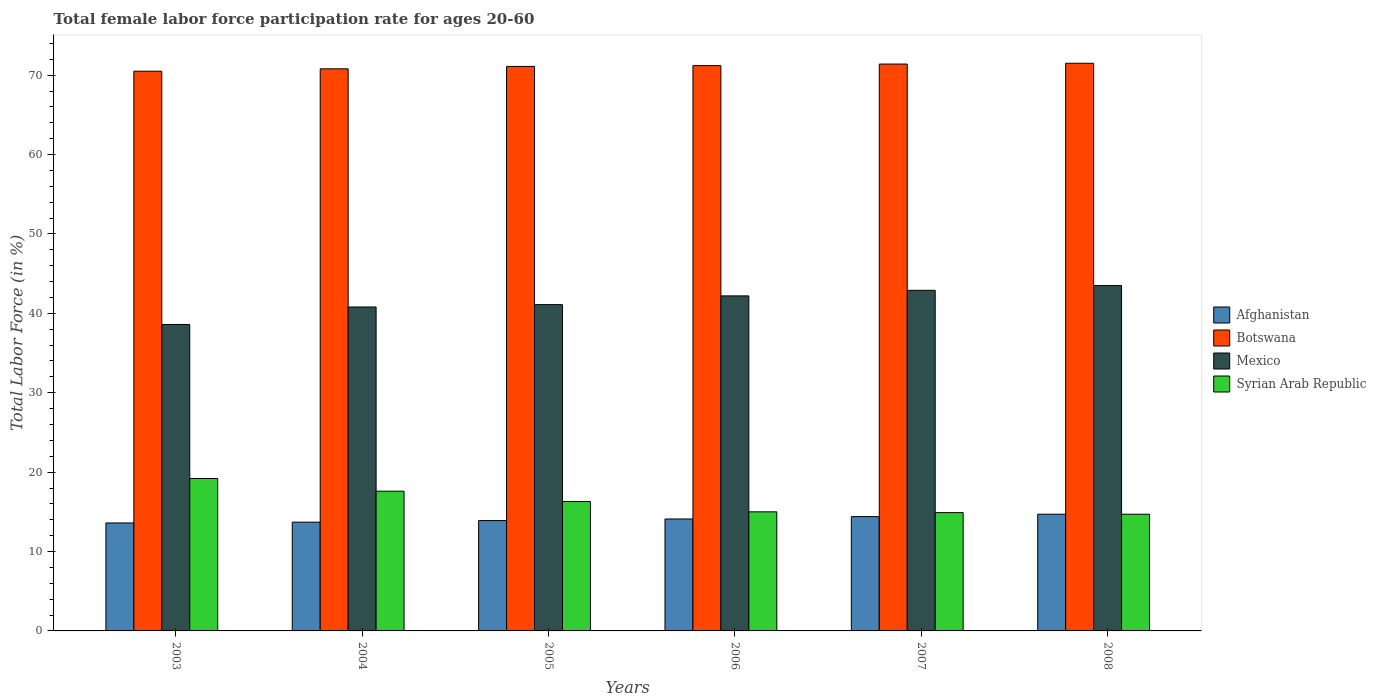How many groups of bars are there?
Offer a terse response. 6. Are the number of bars per tick equal to the number of legend labels?
Offer a very short reply. Yes. Are the number of bars on each tick of the X-axis equal?
Offer a very short reply. Yes. In how many cases, is the number of bars for a given year not equal to the number of legend labels?
Provide a short and direct response. 0. What is the female labor force participation rate in Syrian Arab Republic in 2006?
Your answer should be compact. 15. Across all years, what is the maximum female labor force participation rate in Botswana?
Keep it short and to the point. 71.5. Across all years, what is the minimum female labor force participation rate in Afghanistan?
Ensure brevity in your answer.  13.6. What is the total female labor force participation rate in Syrian Arab Republic in the graph?
Give a very brief answer. 97.7. What is the difference between the female labor force participation rate in Syrian Arab Republic in 2006 and that in 2008?
Provide a short and direct response. 0.3. What is the difference between the female labor force participation rate in Afghanistan in 2007 and the female labor force participation rate in Syrian Arab Republic in 2003?
Keep it short and to the point. -4.8. What is the average female labor force participation rate in Mexico per year?
Provide a succinct answer. 41.52. In the year 2006, what is the difference between the female labor force participation rate in Syrian Arab Republic and female labor force participation rate in Botswana?
Provide a short and direct response. -56.2. In how many years, is the female labor force participation rate in Syrian Arab Republic greater than 44 %?
Provide a succinct answer. 0. What is the ratio of the female labor force participation rate in Mexico in 2004 to that in 2006?
Ensure brevity in your answer.  0.97. Is the female labor force participation rate in Afghanistan in 2003 less than that in 2007?
Provide a short and direct response. Yes. Is the difference between the female labor force participation rate in Syrian Arab Republic in 2006 and 2007 greater than the difference between the female labor force participation rate in Botswana in 2006 and 2007?
Your answer should be compact. Yes. What is the difference between the highest and the second highest female labor force participation rate in Botswana?
Make the answer very short. 0.1. What is the difference between the highest and the lowest female labor force participation rate in Botswana?
Your answer should be very brief. 1. Is the sum of the female labor force participation rate in Syrian Arab Republic in 2005 and 2007 greater than the maximum female labor force participation rate in Afghanistan across all years?
Provide a short and direct response. Yes. What does the 3rd bar from the left in 2007 represents?
Your answer should be compact. Mexico. Is it the case that in every year, the sum of the female labor force participation rate in Afghanistan and female labor force participation rate in Mexico is greater than the female labor force participation rate in Botswana?
Offer a terse response. No. Are all the bars in the graph horizontal?
Your answer should be very brief. No. How many years are there in the graph?
Ensure brevity in your answer.  6. What is the difference between two consecutive major ticks on the Y-axis?
Ensure brevity in your answer.  10. How many legend labels are there?
Ensure brevity in your answer.  4. How are the legend labels stacked?
Ensure brevity in your answer.  Vertical. What is the title of the graph?
Your answer should be very brief. Total female labor force participation rate for ages 20-60. Does "Uzbekistan" appear as one of the legend labels in the graph?
Offer a terse response. No. What is the label or title of the X-axis?
Your answer should be compact. Years. What is the Total Labor Force (in %) of Afghanistan in 2003?
Your answer should be very brief. 13.6. What is the Total Labor Force (in %) of Botswana in 2003?
Your response must be concise. 70.5. What is the Total Labor Force (in %) of Mexico in 2003?
Your response must be concise. 38.6. What is the Total Labor Force (in %) in Syrian Arab Republic in 2003?
Give a very brief answer. 19.2. What is the Total Labor Force (in %) in Afghanistan in 2004?
Your answer should be very brief. 13.7. What is the Total Labor Force (in %) of Botswana in 2004?
Offer a very short reply. 70.8. What is the Total Labor Force (in %) in Mexico in 2004?
Make the answer very short. 40.8. What is the Total Labor Force (in %) in Syrian Arab Republic in 2004?
Offer a terse response. 17.6. What is the Total Labor Force (in %) of Afghanistan in 2005?
Your response must be concise. 13.9. What is the Total Labor Force (in %) of Botswana in 2005?
Keep it short and to the point. 71.1. What is the Total Labor Force (in %) of Mexico in 2005?
Your response must be concise. 41.1. What is the Total Labor Force (in %) of Syrian Arab Republic in 2005?
Ensure brevity in your answer.  16.3. What is the Total Labor Force (in %) of Afghanistan in 2006?
Offer a very short reply. 14.1. What is the Total Labor Force (in %) of Botswana in 2006?
Your answer should be compact. 71.2. What is the Total Labor Force (in %) of Mexico in 2006?
Your response must be concise. 42.2. What is the Total Labor Force (in %) of Syrian Arab Republic in 2006?
Provide a succinct answer. 15. What is the Total Labor Force (in %) of Afghanistan in 2007?
Give a very brief answer. 14.4. What is the Total Labor Force (in %) of Botswana in 2007?
Offer a terse response. 71.4. What is the Total Labor Force (in %) of Mexico in 2007?
Provide a succinct answer. 42.9. What is the Total Labor Force (in %) in Syrian Arab Republic in 2007?
Provide a short and direct response. 14.9. What is the Total Labor Force (in %) of Afghanistan in 2008?
Your answer should be compact. 14.7. What is the Total Labor Force (in %) of Botswana in 2008?
Your answer should be very brief. 71.5. What is the Total Labor Force (in %) in Mexico in 2008?
Make the answer very short. 43.5. What is the Total Labor Force (in %) of Syrian Arab Republic in 2008?
Offer a terse response. 14.7. Across all years, what is the maximum Total Labor Force (in %) in Afghanistan?
Offer a very short reply. 14.7. Across all years, what is the maximum Total Labor Force (in %) in Botswana?
Ensure brevity in your answer.  71.5. Across all years, what is the maximum Total Labor Force (in %) in Mexico?
Offer a terse response. 43.5. Across all years, what is the maximum Total Labor Force (in %) of Syrian Arab Republic?
Your answer should be compact. 19.2. Across all years, what is the minimum Total Labor Force (in %) of Afghanistan?
Keep it short and to the point. 13.6. Across all years, what is the minimum Total Labor Force (in %) in Botswana?
Offer a very short reply. 70.5. Across all years, what is the minimum Total Labor Force (in %) of Mexico?
Offer a terse response. 38.6. Across all years, what is the minimum Total Labor Force (in %) of Syrian Arab Republic?
Your response must be concise. 14.7. What is the total Total Labor Force (in %) in Afghanistan in the graph?
Your response must be concise. 84.4. What is the total Total Labor Force (in %) of Botswana in the graph?
Your response must be concise. 426.5. What is the total Total Labor Force (in %) in Mexico in the graph?
Your answer should be very brief. 249.1. What is the total Total Labor Force (in %) of Syrian Arab Republic in the graph?
Ensure brevity in your answer.  97.7. What is the difference between the Total Labor Force (in %) of Syrian Arab Republic in 2003 and that in 2004?
Make the answer very short. 1.6. What is the difference between the Total Labor Force (in %) of Mexico in 2003 and that in 2005?
Keep it short and to the point. -2.5. What is the difference between the Total Labor Force (in %) in Afghanistan in 2003 and that in 2006?
Your answer should be very brief. -0.5. What is the difference between the Total Labor Force (in %) of Botswana in 2003 and that in 2006?
Your answer should be compact. -0.7. What is the difference between the Total Labor Force (in %) of Mexico in 2003 and that in 2006?
Ensure brevity in your answer.  -3.6. What is the difference between the Total Labor Force (in %) in Syrian Arab Republic in 2003 and that in 2006?
Provide a short and direct response. 4.2. What is the difference between the Total Labor Force (in %) in Botswana in 2003 and that in 2007?
Offer a very short reply. -0.9. What is the difference between the Total Labor Force (in %) in Mexico in 2003 and that in 2007?
Make the answer very short. -4.3. What is the difference between the Total Labor Force (in %) in Afghanistan in 2004 and that in 2005?
Your response must be concise. -0.2. What is the difference between the Total Labor Force (in %) in Botswana in 2004 and that in 2005?
Keep it short and to the point. -0.3. What is the difference between the Total Labor Force (in %) of Mexico in 2004 and that in 2005?
Ensure brevity in your answer.  -0.3. What is the difference between the Total Labor Force (in %) in Syrian Arab Republic in 2004 and that in 2005?
Provide a succinct answer. 1.3. What is the difference between the Total Labor Force (in %) of Botswana in 2004 and that in 2006?
Offer a terse response. -0.4. What is the difference between the Total Labor Force (in %) in Mexico in 2004 and that in 2006?
Make the answer very short. -1.4. What is the difference between the Total Labor Force (in %) in Botswana in 2004 and that in 2007?
Ensure brevity in your answer.  -0.6. What is the difference between the Total Labor Force (in %) in Syrian Arab Republic in 2004 and that in 2007?
Offer a very short reply. 2.7. What is the difference between the Total Labor Force (in %) in Botswana in 2004 and that in 2008?
Offer a terse response. -0.7. What is the difference between the Total Labor Force (in %) in Mexico in 2004 and that in 2008?
Ensure brevity in your answer.  -2.7. What is the difference between the Total Labor Force (in %) in Syrian Arab Republic in 2004 and that in 2008?
Your response must be concise. 2.9. What is the difference between the Total Labor Force (in %) of Afghanistan in 2005 and that in 2006?
Your answer should be very brief. -0.2. What is the difference between the Total Labor Force (in %) in Botswana in 2005 and that in 2006?
Your response must be concise. -0.1. What is the difference between the Total Labor Force (in %) in Syrian Arab Republic in 2005 and that in 2006?
Offer a terse response. 1.3. What is the difference between the Total Labor Force (in %) of Botswana in 2005 and that in 2007?
Make the answer very short. -0.3. What is the difference between the Total Labor Force (in %) of Syrian Arab Republic in 2005 and that in 2007?
Offer a very short reply. 1.4. What is the difference between the Total Labor Force (in %) of Afghanistan in 2005 and that in 2008?
Ensure brevity in your answer.  -0.8. What is the difference between the Total Labor Force (in %) of Afghanistan in 2006 and that in 2007?
Keep it short and to the point. -0.3. What is the difference between the Total Labor Force (in %) in Botswana in 2006 and that in 2007?
Your answer should be compact. -0.2. What is the difference between the Total Labor Force (in %) in Afghanistan in 2006 and that in 2008?
Offer a terse response. -0.6. What is the difference between the Total Labor Force (in %) of Botswana in 2006 and that in 2008?
Your answer should be very brief. -0.3. What is the difference between the Total Labor Force (in %) of Mexico in 2006 and that in 2008?
Provide a short and direct response. -1.3. What is the difference between the Total Labor Force (in %) in Syrian Arab Republic in 2006 and that in 2008?
Your response must be concise. 0.3. What is the difference between the Total Labor Force (in %) in Afghanistan in 2007 and that in 2008?
Give a very brief answer. -0.3. What is the difference between the Total Labor Force (in %) of Botswana in 2007 and that in 2008?
Your response must be concise. -0.1. What is the difference between the Total Labor Force (in %) in Mexico in 2007 and that in 2008?
Give a very brief answer. -0.6. What is the difference between the Total Labor Force (in %) in Afghanistan in 2003 and the Total Labor Force (in %) in Botswana in 2004?
Offer a very short reply. -57.2. What is the difference between the Total Labor Force (in %) of Afghanistan in 2003 and the Total Labor Force (in %) of Mexico in 2004?
Make the answer very short. -27.2. What is the difference between the Total Labor Force (in %) in Botswana in 2003 and the Total Labor Force (in %) in Mexico in 2004?
Keep it short and to the point. 29.7. What is the difference between the Total Labor Force (in %) of Botswana in 2003 and the Total Labor Force (in %) of Syrian Arab Republic in 2004?
Keep it short and to the point. 52.9. What is the difference between the Total Labor Force (in %) of Afghanistan in 2003 and the Total Labor Force (in %) of Botswana in 2005?
Make the answer very short. -57.5. What is the difference between the Total Labor Force (in %) of Afghanistan in 2003 and the Total Labor Force (in %) of Mexico in 2005?
Your response must be concise. -27.5. What is the difference between the Total Labor Force (in %) in Botswana in 2003 and the Total Labor Force (in %) in Mexico in 2005?
Make the answer very short. 29.4. What is the difference between the Total Labor Force (in %) in Botswana in 2003 and the Total Labor Force (in %) in Syrian Arab Republic in 2005?
Ensure brevity in your answer.  54.2. What is the difference between the Total Labor Force (in %) of Mexico in 2003 and the Total Labor Force (in %) of Syrian Arab Republic in 2005?
Offer a terse response. 22.3. What is the difference between the Total Labor Force (in %) of Afghanistan in 2003 and the Total Labor Force (in %) of Botswana in 2006?
Offer a very short reply. -57.6. What is the difference between the Total Labor Force (in %) of Afghanistan in 2003 and the Total Labor Force (in %) of Mexico in 2006?
Give a very brief answer. -28.6. What is the difference between the Total Labor Force (in %) of Afghanistan in 2003 and the Total Labor Force (in %) of Syrian Arab Republic in 2006?
Provide a succinct answer. -1.4. What is the difference between the Total Labor Force (in %) of Botswana in 2003 and the Total Labor Force (in %) of Mexico in 2006?
Give a very brief answer. 28.3. What is the difference between the Total Labor Force (in %) of Botswana in 2003 and the Total Labor Force (in %) of Syrian Arab Republic in 2006?
Keep it short and to the point. 55.5. What is the difference between the Total Labor Force (in %) of Mexico in 2003 and the Total Labor Force (in %) of Syrian Arab Republic in 2006?
Ensure brevity in your answer.  23.6. What is the difference between the Total Labor Force (in %) of Afghanistan in 2003 and the Total Labor Force (in %) of Botswana in 2007?
Give a very brief answer. -57.8. What is the difference between the Total Labor Force (in %) in Afghanistan in 2003 and the Total Labor Force (in %) in Mexico in 2007?
Your response must be concise. -29.3. What is the difference between the Total Labor Force (in %) in Botswana in 2003 and the Total Labor Force (in %) in Mexico in 2007?
Keep it short and to the point. 27.6. What is the difference between the Total Labor Force (in %) in Botswana in 2003 and the Total Labor Force (in %) in Syrian Arab Republic in 2007?
Your answer should be compact. 55.6. What is the difference between the Total Labor Force (in %) of Mexico in 2003 and the Total Labor Force (in %) of Syrian Arab Republic in 2007?
Offer a terse response. 23.7. What is the difference between the Total Labor Force (in %) in Afghanistan in 2003 and the Total Labor Force (in %) in Botswana in 2008?
Your response must be concise. -57.9. What is the difference between the Total Labor Force (in %) of Afghanistan in 2003 and the Total Labor Force (in %) of Mexico in 2008?
Keep it short and to the point. -29.9. What is the difference between the Total Labor Force (in %) of Afghanistan in 2003 and the Total Labor Force (in %) of Syrian Arab Republic in 2008?
Make the answer very short. -1.1. What is the difference between the Total Labor Force (in %) of Botswana in 2003 and the Total Labor Force (in %) of Syrian Arab Republic in 2008?
Your answer should be very brief. 55.8. What is the difference between the Total Labor Force (in %) of Mexico in 2003 and the Total Labor Force (in %) of Syrian Arab Republic in 2008?
Offer a very short reply. 23.9. What is the difference between the Total Labor Force (in %) in Afghanistan in 2004 and the Total Labor Force (in %) in Botswana in 2005?
Provide a short and direct response. -57.4. What is the difference between the Total Labor Force (in %) in Afghanistan in 2004 and the Total Labor Force (in %) in Mexico in 2005?
Offer a terse response. -27.4. What is the difference between the Total Labor Force (in %) in Botswana in 2004 and the Total Labor Force (in %) in Mexico in 2005?
Your answer should be compact. 29.7. What is the difference between the Total Labor Force (in %) in Botswana in 2004 and the Total Labor Force (in %) in Syrian Arab Republic in 2005?
Provide a succinct answer. 54.5. What is the difference between the Total Labor Force (in %) in Mexico in 2004 and the Total Labor Force (in %) in Syrian Arab Republic in 2005?
Your response must be concise. 24.5. What is the difference between the Total Labor Force (in %) in Afghanistan in 2004 and the Total Labor Force (in %) in Botswana in 2006?
Make the answer very short. -57.5. What is the difference between the Total Labor Force (in %) of Afghanistan in 2004 and the Total Labor Force (in %) of Mexico in 2006?
Offer a very short reply. -28.5. What is the difference between the Total Labor Force (in %) in Botswana in 2004 and the Total Labor Force (in %) in Mexico in 2006?
Ensure brevity in your answer.  28.6. What is the difference between the Total Labor Force (in %) of Botswana in 2004 and the Total Labor Force (in %) of Syrian Arab Republic in 2006?
Provide a short and direct response. 55.8. What is the difference between the Total Labor Force (in %) in Mexico in 2004 and the Total Labor Force (in %) in Syrian Arab Republic in 2006?
Offer a terse response. 25.8. What is the difference between the Total Labor Force (in %) in Afghanistan in 2004 and the Total Labor Force (in %) in Botswana in 2007?
Offer a terse response. -57.7. What is the difference between the Total Labor Force (in %) in Afghanistan in 2004 and the Total Labor Force (in %) in Mexico in 2007?
Give a very brief answer. -29.2. What is the difference between the Total Labor Force (in %) of Afghanistan in 2004 and the Total Labor Force (in %) of Syrian Arab Republic in 2007?
Offer a very short reply. -1.2. What is the difference between the Total Labor Force (in %) of Botswana in 2004 and the Total Labor Force (in %) of Mexico in 2007?
Ensure brevity in your answer.  27.9. What is the difference between the Total Labor Force (in %) in Botswana in 2004 and the Total Labor Force (in %) in Syrian Arab Republic in 2007?
Your answer should be very brief. 55.9. What is the difference between the Total Labor Force (in %) of Mexico in 2004 and the Total Labor Force (in %) of Syrian Arab Republic in 2007?
Your answer should be very brief. 25.9. What is the difference between the Total Labor Force (in %) in Afghanistan in 2004 and the Total Labor Force (in %) in Botswana in 2008?
Make the answer very short. -57.8. What is the difference between the Total Labor Force (in %) of Afghanistan in 2004 and the Total Labor Force (in %) of Mexico in 2008?
Provide a short and direct response. -29.8. What is the difference between the Total Labor Force (in %) in Afghanistan in 2004 and the Total Labor Force (in %) in Syrian Arab Republic in 2008?
Ensure brevity in your answer.  -1. What is the difference between the Total Labor Force (in %) in Botswana in 2004 and the Total Labor Force (in %) in Mexico in 2008?
Provide a short and direct response. 27.3. What is the difference between the Total Labor Force (in %) in Botswana in 2004 and the Total Labor Force (in %) in Syrian Arab Republic in 2008?
Make the answer very short. 56.1. What is the difference between the Total Labor Force (in %) of Mexico in 2004 and the Total Labor Force (in %) of Syrian Arab Republic in 2008?
Ensure brevity in your answer.  26.1. What is the difference between the Total Labor Force (in %) of Afghanistan in 2005 and the Total Labor Force (in %) of Botswana in 2006?
Make the answer very short. -57.3. What is the difference between the Total Labor Force (in %) of Afghanistan in 2005 and the Total Labor Force (in %) of Mexico in 2006?
Provide a succinct answer. -28.3. What is the difference between the Total Labor Force (in %) in Botswana in 2005 and the Total Labor Force (in %) in Mexico in 2006?
Offer a terse response. 28.9. What is the difference between the Total Labor Force (in %) in Botswana in 2005 and the Total Labor Force (in %) in Syrian Arab Republic in 2006?
Your answer should be very brief. 56.1. What is the difference between the Total Labor Force (in %) in Mexico in 2005 and the Total Labor Force (in %) in Syrian Arab Republic in 2006?
Keep it short and to the point. 26.1. What is the difference between the Total Labor Force (in %) in Afghanistan in 2005 and the Total Labor Force (in %) in Botswana in 2007?
Provide a succinct answer. -57.5. What is the difference between the Total Labor Force (in %) of Afghanistan in 2005 and the Total Labor Force (in %) of Mexico in 2007?
Your answer should be very brief. -29. What is the difference between the Total Labor Force (in %) in Afghanistan in 2005 and the Total Labor Force (in %) in Syrian Arab Republic in 2007?
Offer a very short reply. -1. What is the difference between the Total Labor Force (in %) in Botswana in 2005 and the Total Labor Force (in %) in Mexico in 2007?
Give a very brief answer. 28.2. What is the difference between the Total Labor Force (in %) in Botswana in 2005 and the Total Labor Force (in %) in Syrian Arab Republic in 2007?
Provide a succinct answer. 56.2. What is the difference between the Total Labor Force (in %) in Mexico in 2005 and the Total Labor Force (in %) in Syrian Arab Republic in 2007?
Provide a short and direct response. 26.2. What is the difference between the Total Labor Force (in %) in Afghanistan in 2005 and the Total Labor Force (in %) in Botswana in 2008?
Ensure brevity in your answer.  -57.6. What is the difference between the Total Labor Force (in %) in Afghanistan in 2005 and the Total Labor Force (in %) in Mexico in 2008?
Your answer should be very brief. -29.6. What is the difference between the Total Labor Force (in %) of Botswana in 2005 and the Total Labor Force (in %) of Mexico in 2008?
Offer a very short reply. 27.6. What is the difference between the Total Labor Force (in %) of Botswana in 2005 and the Total Labor Force (in %) of Syrian Arab Republic in 2008?
Make the answer very short. 56.4. What is the difference between the Total Labor Force (in %) of Mexico in 2005 and the Total Labor Force (in %) of Syrian Arab Republic in 2008?
Offer a terse response. 26.4. What is the difference between the Total Labor Force (in %) of Afghanistan in 2006 and the Total Labor Force (in %) of Botswana in 2007?
Offer a very short reply. -57.3. What is the difference between the Total Labor Force (in %) in Afghanistan in 2006 and the Total Labor Force (in %) in Mexico in 2007?
Ensure brevity in your answer.  -28.8. What is the difference between the Total Labor Force (in %) of Afghanistan in 2006 and the Total Labor Force (in %) of Syrian Arab Republic in 2007?
Provide a succinct answer. -0.8. What is the difference between the Total Labor Force (in %) of Botswana in 2006 and the Total Labor Force (in %) of Mexico in 2007?
Keep it short and to the point. 28.3. What is the difference between the Total Labor Force (in %) in Botswana in 2006 and the Total Labor Force (in %) in Syrian Arab Republic in 2007?
Provide a short and direct response. 56.3. What is the difference between the Total Labor Force (in %) in Mexico in 2006 and the Total Labor Force (in %) in Syrian Arab Republic in 2007?
Keep it short and to the point. 27.3. What is the difference between the Total Labor Force (in %) in Afghanistan in 2006 and the Total Labor Force (in %) in Botswana in 2008?
Provide a short and direct response. -57.4. What is the difference between the Total Labor Force (in %) of Afghanistan in 2006 and the Total Labor Force (in %) of Mexico in 2008?
Your answer should be very brief. -29.4. What is the difference between the Total Labor Force (in %) in Afghanistan in 2006 and the Total Labor Force (in %) in Syrian Arab Republic in 2008?
Ensure brevity in your answer.  -0.6. What is the difference between the Total Labor Force (in %) in Botswana in 2006 and the Total Labor Force (in %) in Mexico in 2008?
Offer a terse response. 27.7. What is the difference between the Total Labor Force (in %) of Botswana in 2006 and the Total Labor Force (in %) of Syrian Arab Republic in 2008?
Keep it short and to the point. 56.5. What is the difference between the Total Labor Force (in %) of Afghanistan in 2007 and the Total Labor Force (in %) of Botswana in 2008?
Your answer should be compact. -57.1. What is the difference between the Total Labor Force (in %) of Afghanistan in 2007 and the Total Labor Force (in %) of Mexico in 2008?
Your answer should be compact. -29.1. What is the difference between the Total Labor Force (in %) in Afghanistan in 2007 and the Total Labor Force (in %) in Syrian Arab Republic in 2008?
Provide a succinct answer. -0.3. What is the difference between the Total Labor Force (in %) in Botswana in 2007 and the Total Labor Force (in %) in Mexico in 2008?
Give a very brief answer. 27.9. What is the difference between the Total Labor Force (in %) in Botswana in 2007 and the Total Labor Force (in %) in Syrian Arab Republic in 2008?
Give a very brief answer. 56.7. What is the difference between the Total Labor Force (in %) in Mexico in 2007 and the Total Labor Force (in %) in Syrian Arab Republic in 2008?
Your answer should be very brief. 28.2. What is the average Total Labor Force (in %) of Afghanistan per year?
Your answer should be very brief. 14.07. What is the average Total Labor Force (in %) in Botswana per year?
Offer a terse response. 71.08. What is the average Total Labor Force (in %) of Mexico per year?
Make the answer very short. 41.52. What is the average Total Labor Force (in %) in Syrian Arab Republic per year?
Your answer should be compact. 16.28. In the year 2003, what is the difference between the Total Labor Force (in %) in Afghanistan and Total Labor Force (in %) in Botswana?
Your answer should be very brief. -56.9. In the year 2003, what is the difference between the Total Labor Force (in %) in Botswana and Total Labor Force (in %) in Mexico?
Ensure brevity in your answer.  31.9. In the year 2003, what is the difference between the Total Labor Force (in %) of Botswana and Total Labor Force (in %) of Syrian Arab Republic?
Your answer should be compact. 51.3. In the year 2003, what is the difference between the Total Labor Force (in %) of Mexico and Total Labor Force (in %) of Syrian Arab Republic?
Your answer should be compact. 19.4. In the year 2004, what is the difference between the Total Labor Force (in %) of Afghanistan and Total Labor Force (in %) of Botswana?
Your answer should be compact. -57.1. In the year 2004, what is the difference between the Total Labor Force (in %) in Afghanistan and Total Labor Force (in %) in Mexico?
Ensure brevity in your answer.  -27.1. In the year 2004, what is the difference between the Total Labor Force (in %) of Afghanistan and Total Labor Force (in %) of Syrian Arab Republic?
Your response must be concise. -3.9. In the year 2004, what is the difference between the Total Labor Force (in %) in Botswana and Total Labor Force (in %) in Mexico?
Your answer should be compact. 30. In the year 2004, what is the difference between the Total Labor Force (in %) in Botswana and Total Labor Force (in %) in Syrian Arab Republic?
Offer a very short reply. 53.2. In the year 2004, what is the difference between the Total Labor Force (in %) in Mexico and Total Labor Force (in %) in Syrian Arab Republic?
Keep it short and to the point. 23.2. In the year 2005, what is the difference between the Total Labor Force (in %) in Afghanistan and Total Labor Force (in %) in Botswana?
Make the answer very short. -57.2. In the year 2005, what is the difference between the Total Labor Force (in %) of Afghanistan and Total Labor Force (in %) of Mexico?
Offer a very short reply. -27.2. In the year 2005, what is the difference between the Total Labor Force (in %) of Botswana and Total Labor Force (in %) of Mexico?
Ensure brevity in your answer.  30. In the year 2005, what is the difference between the Total Labor Force (in %) of Botswana and Total Labor Force (in %) of Syrian Arab Republic?
Your answer should be very brief. 54.8. In the year 2005, what is the difference between the Total Labor Force (in %) of Mexico and Total Labor Force (in %) of Syrian Arab Republic?
Provide a short and direct response. 24.8. In the year 2006, what is the difference between the Total Labor Force (in %) in Afghanistan and Total Labor Force (in %) in Botswana?
Give a very brief answer. -57.1. In the year 2006, what is the difference between the Total Labor Force (in %) of Afghanistan and Total Labor Force (in %) of Mexico?
Provide a succinct answer. -28.1. In the year 2006, what is the difference between the Total Labor Force (in %) of Botswana and Total Labor Force (in %) of Mexico?
Provide a short and direct response. 29. In the year 2006, what is the difference between the Total Labor Force (in %) in Botswana and Total Labor Force (in %) in Syrian Arab Republic?
Your response must be concise. 56.2. In the year 2006, what is the difference between the Total Labor Force (in %) of Mexico and Total Labor Force (in %) of Syrian Arab Republic?
Offer a very short reply. 27.2. In the year 2007, what is the difference between the Total Labor Force (in %) in Afghanistan and Total Labor Force (in %) in Botswana?
Make the answer very short. -57. In the year 2007, what is the difference between the Total Labor Force (in %) in Afghanistan and Total Labor Force (in %) in Mexico?
Your response must be concise. -28.5. In the year 2007, what is the difference between the Total Labor Force (in %) of Botswana and Total Labor Force (in %) of Mexico?
Your answer should be compact. 28.5. In the year 2007, what is the difference between the Total Labor Force (in %) of Botswana and Total Labor Force (in %) of Syrian Arab Republic?
Give a very brief answer. 56.5. In the year 2008, what is the difference between the Total Labor Force (in %) in Afghanistan and Total Labor Force (in %) in Botswana?
Your answer should be very brief. -56.8. In the year 2008, what is the difference between the Total Labor Force (in %) of Afghanistan and Total Labor Force (in %) of Mexico?
Provide a succinct answer. -28.8. In the year 2008, what is the difference between the Total Labor Force (in %) in Afghanistan and Total Labor Force (in %) in Syrian Arab Republic?
Provide a succinct answer. 0. In the year 2008, what is the difference between the Total Labor Force (in %) in Botswana and Total Labor Force (in %) in Syrian Arab Republic?
Provide a short and direct response. 56.8. In the year 2008, what is the difference between the Total Labor Force (in %) of Mexico and Total Labor Force (in %) of Syrian Arab Republic?
Your response must be concise. 28.8. What is the ratio of the Total Labor Force (in %) in Afghanistan in 2003 to that in 2004?
Your answer should be very brief. 0.99. What is the ratio of the Total Labor Force (in %) in Botswana in 2003 to that in 2004?
Provide a succinct answer. 1. What is the ratio of the Total Labor Force (in %) of Mexico in 2003 to that in 2004?
Keep it short and to the point. 0.95. What is the ratio of the Total Labor Force (in %) in Afghanistan in 2003 to that in 2005?
Give a very brief answer. 0.98. What is the ratio of the Total Labor Force (in %) in Mexico in 2003 to that in 2005?
Ensure brevity in your answer.  0.94. What is the ratio of the Total Labor Force (in %) in Syrian Arab Republic in 2003 to that in 2005?
Make the answer very short. 1.18. What is the ratio of the Total Labor Force (in %) of Afghanistan in 2003 to that in 2006?
Provide a short and direct response. 0.96. What is the ratio of the Total Labor Force (in %) in Botswana in 2003 to that in 2006?
Offer a terse response. 0.99. What is the ratio of the Total Labor Force (in %) of Mexico in 2003 to that in 2006?
Provide a short and direct response. 0.91. What is the ratio of the Total Labor Force (in %) of Syrian Arab Republic in 2003 to that in 2006?
Provide a succinct answer. 1.28. What is the ratio of the Total Labor Force (in %) of Botswana in 2003 to that in 2007?
Your answer should be compact. 0.99. What is the ratio of the Total Labor Force (in %) of Mexico in 2003 to that in 2007?
Offer a terse response. 0.9. What is the ratio of the Total Labor Force (in %) of Syrian Arab Republic in 2003 to that in 2007?
Provide a short and direct response. 1.29. What is the ratio of the Total Labor Force (in %) in Afghanistan in 2003 to that in 2008?
Your answer should be compact. 0.93. What is the ratio of the Total Labor Force (in %) in Mexico in 2003 to that in 2008?
Your answer should be very brief. 0.89. What is the ratio of the Total Labor Force (in %) in Syrian Arab Republic in 2003 to that in 2008?
Your answer should be very brief. 1.31. What is the ratio of the Total Labor Force (in %) in Afghanistan in 2004 to that in 2005?
Your response must be concise. 0.99. What is the ratio of the Total Labor Force (in %) of Syrian Arab Republic in 2004 to that in 2005?
Provide a succinct answer. 1.08. What is the ratio of the Total Labor Force (in %) of Afghanistan in 2004 to that in 2006?
Your answer should be compact. 0.97. What is the ratio of the Total Labor Force (in %) of Botswana in 2004 to that in 2006?
Your answer should be compact. 0.99. What is the ratio of the Total Labor Force (in %) of Mexico in 2004 to that in 2006?
Offer a very short reply. 0.97. What is the ratio of the Total Labor Force (in %) in Syrian Arab Republic in 2004 to that in 2006?
Ensure brevity in your answer.  1.17. What is the ratio of the Total Labor Force (in %) of Afghanistan in 2004 to that in 2007?
Ensure brevity in your answer.  0.95. What is the ratio of the Total Labor Force (in %) of Botswana in 2004 to that in 2007?
Provide a succinct answer. 0.99. What is the ratio of the Total Labor Force (in %) in Mexico in 2004 to that in 2007?
Your answer should be compact. 0.95. What is the ratio of the Total Labor Force (in %) in Syrian Arab Republic in 2004 to that in 2007?
Your answer should be compact. 1.18. What is the ratio of the Total Labor Force (in %) in Afghanistan in 2004 to that in 2008?
Make the answer very short. 0.93. What is the ratio of the Total Labor Force (in %) in Botswana in 2004 to that in 2008?
Your answer should be compact. 0.99. What is the ratio of the Total Labor Force (in %) of Mexico in 2004 to that in 2008?
Provide a short and direct response. 0.94. What is the ratio of the Total Labor Force (in %) in Syrian Arab Republic in 2004 to that in 2008?
Offer a very short reply. 1.2. What is the ratio of the Total Labor Force (in %) of Afghanistan in 2005 to that in 2006?
Provide a succinct answer. 0.99. What is the ratio of the Total Labor Force (in %) of Mexico in 2005 to that in 2006?
Give a very brief answer. 0.97. What is the ratio of the Total Labor Force (in %) of Syrian Arab Republic in 2005 to that in 2006?
Keep it short and to the point. 1.09. What is the ratio of the Total Labor Force (in %) in Afghanistan in 2005 to that in 2007?
Your response must be concise. 0.97. What is the ratio of the Total Labor Force (in %) in Botswana in 2005 to that in 2007?
Provide a short and direct response. 1. What is the ratio of the Total Labor Force (in %) in Mexico in 2005 to that in 2007?
Offer a terse response. 0.96. What is the ratio of the Total Labor Force (in %) of Syrian Arab Republic in 2005 to that in 2007?
Make the answer very short. 1.09. What is the ratio of the Total Labor Force (in %) of Afghanistan in 2005 to that in 2008?
Your answer should be compact. 0.95. What is the ratio of the Total Labor Force (in %) in Mexico in 2005 to that in 2008?
Offer a very short reply. 0.94. What is the ratio of the Total Labor Force (in %) of Syrian Arab Republic in 2005 to that in 2008?
Give a very brief answer. 1.11. What is the ratio of the Total Labor Force (in %) of Afghanistan in 2006 to that in 2007?
Your answer should be very brief. 0.98. What is the ratio of the Total Labor Force (in %) in Mexico in 2006 to that in 2007?
Make the answer very short. 0.98. What is the ratio of the Total Labor Force (in %) in Syrian Arab Republic in 2006 to that in 2007?
Provide a short and direct response. 1.01. What is the ratio of the Total Labor Force (in %) of Afghanistan in 2006 to that in 2008?
Give a very brief answer. 0.96. What is the ratio of the Total Labor Force (in %) in Botswana in 2006 to that in 2008?
Offer a very short reply. 1. What is the ratio of the Total Labor Force (in %) in Mexico in 2006 to that in 2008?
Keep it short and to the point. 0.97. What is the ratio of the Total Labor Force (in %) of Syrian Arab Republic in 2006 to that in 2008?
Offer a terse response. 1.02. What is the ratio of the Total Labor Force (in %) of Afghanistan in 2007 to that in 2008?
Your answer should be very brief. 0.98. What is the ratio of the Total Labor Force (in %) in Botswana in 2007 to that in 2008?
Ensure brevity in your answer.  1. What is the ratio of the Total Labor Force (in %) of Mexico in 2007 to that in 2008?
Provide a short and direct response. 0.99. What is the ratio of the Total Labor Force (in %) in Syrian Arab Republic in 2007 to that in 2008?
Ensure brevity in your answer.  1.01. What is the difference between the highest and the second highest Total Labor Force (in %) in Mexico?
Keep it short and to the point. 0.6. What is the difference between the highest and the second highest Total Labor Force (in %) in Syrian Arab Republic?
Keep it short and to the point. 1.6. 